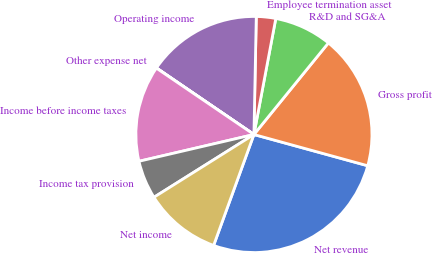Convert chart. <chart><loc_0><loc_0><loc_500><loc_500><pie_chart><fcel>Net revenue<fcel>Gross profit<fcel>R&D and SG&A<fcel>Employee termination asset<fcel>Operating income<fcel>Other expense net<fcel>Income before income taxes<fcel>Income tax provision<fcel>Net income<nl><fcel>26.28%<fcel>18.4%<fcel>7.9%<fcel>2.65%<fcel>15.78%<fcel>0.03%<fcel>13.15%<fcel>5.28%<fcel>10.53%<nl></chart> 